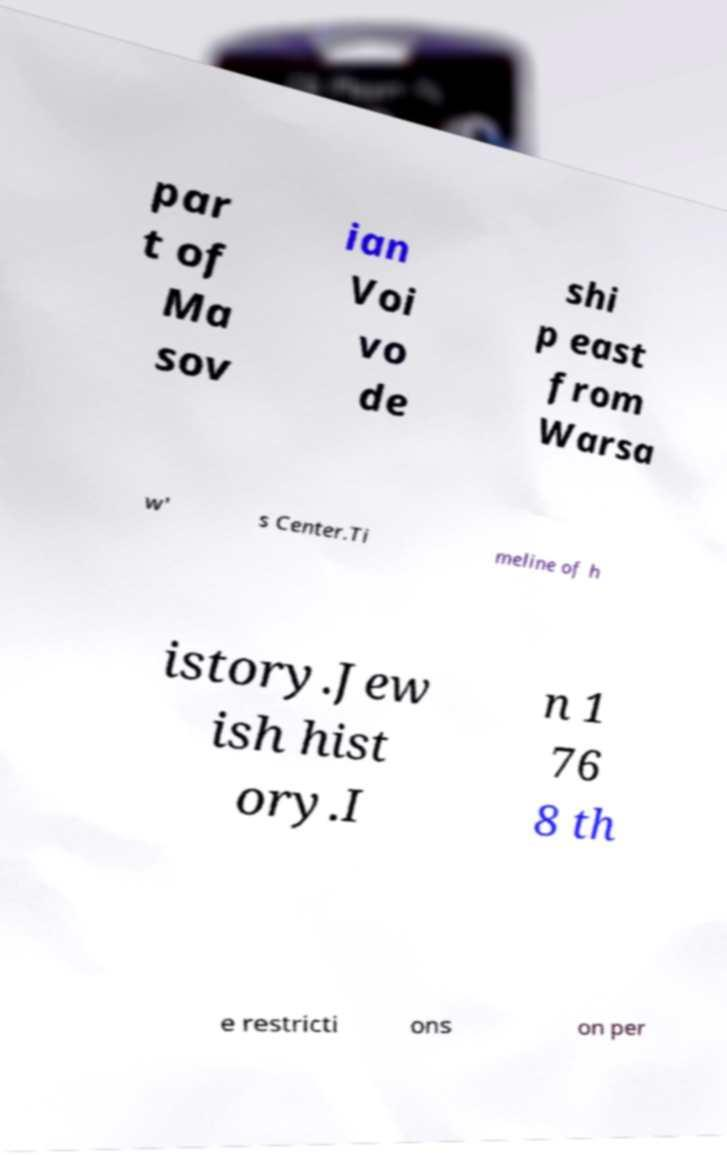I need the written content from this picture converted into text. Can you do that? par t of Ma sov ian Voi vo de shi p east from Warsa w' s Center.Ti meline of h istory.Jew ish hist ory.I n 1 76 8 th e restricti ons on per 